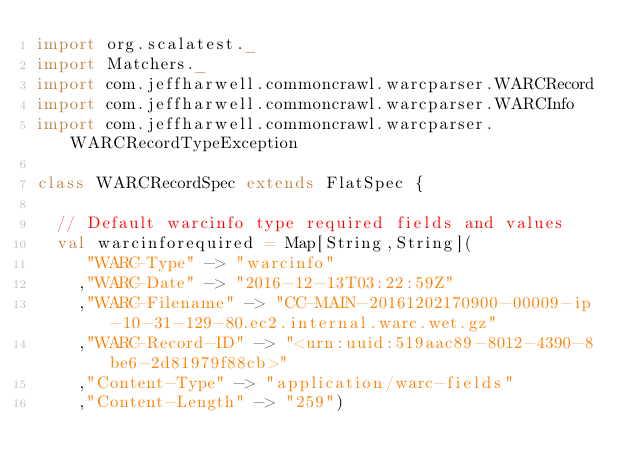<code> <loc_0><loc_0><loc_500><loc_500><_Scala_>import org.scalatest._
import Matchers._
import com.jeffharwell.commoncrawl.warcparser.WARCRecord
import com.jeffharwell.commoncrawl.warcparser.WARCInfo
import com.jeffharwell.commoncrawl.warcparser.WARCRecordTypeException

class WARCRecordSpec extends FlatSpec {

  // Default warcinfo type required fields and values
  val warcinforequired = Map[String,String](
     "WARC-Type" -> "warcinfo"
    ,"WARC-Date" -> "2016-12-13T03:22:59Z"
    ,"WARC-Filename" -> "CC-MAIN-20161202170900-00009-ip-10-31-129-80.ec2.internal.warc.wet.gz"
    ,"WARC-Record-ID" -> "<urn:uuid:519aac89-8012-4390-8be6-2d81979f88cb>"
    ,"Content-Type" -> "application/warc-fields"
    ,"Content-Length" -> "259")
</code> 